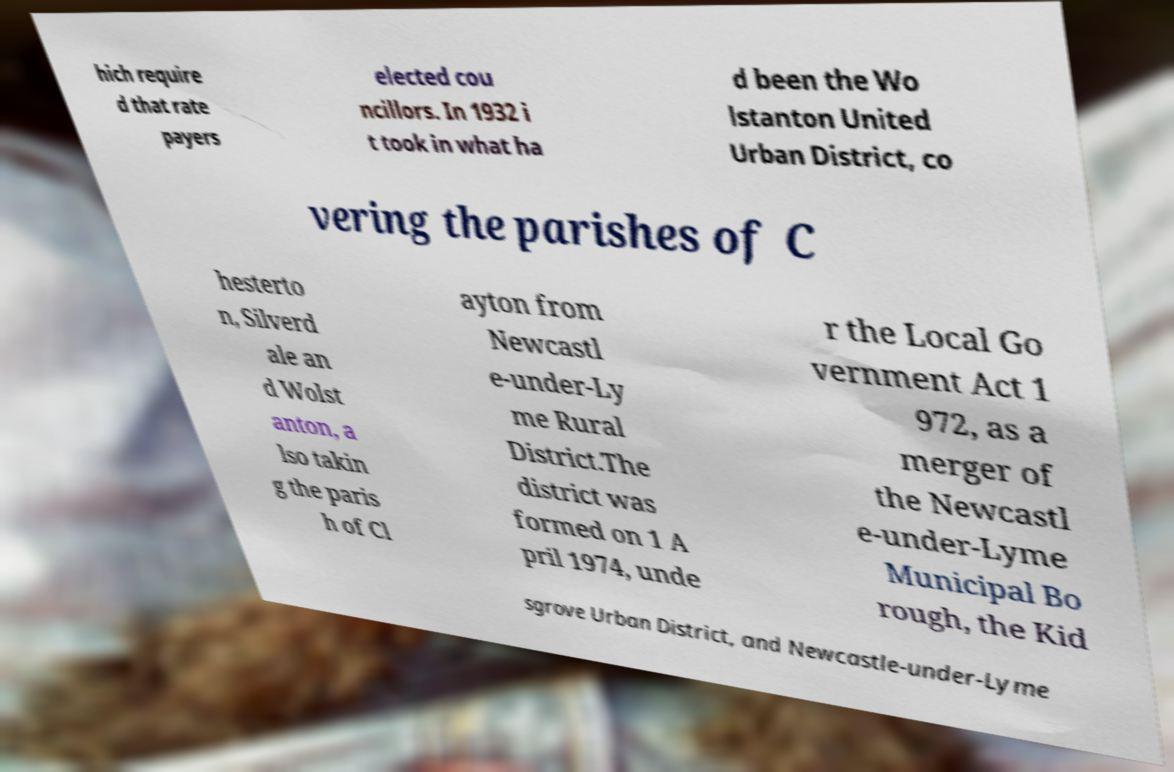Can you read and provide the text displayed in the image?This photo seems to have some interesting text. Can you extract and type it out for me? hich require d that rate payers elected cou ncillors. In 1932 i t took in what ha d been the Wo lstanton United Urban District, co vering the parishes of C hesterto n, Silverd ale an d Wolst anton, a lso takin g the paris h of Cl ayton from Newcastl e-under-Ly me Rural District.The district was formed on 1 A pril 1974, unde r the Local Go vernment Act 1 972, as a merger of the Newcastl e-under-Lyme Municipal Bo rough, the Kid sgrove Urban District, and Newcastle-under-Lyme 